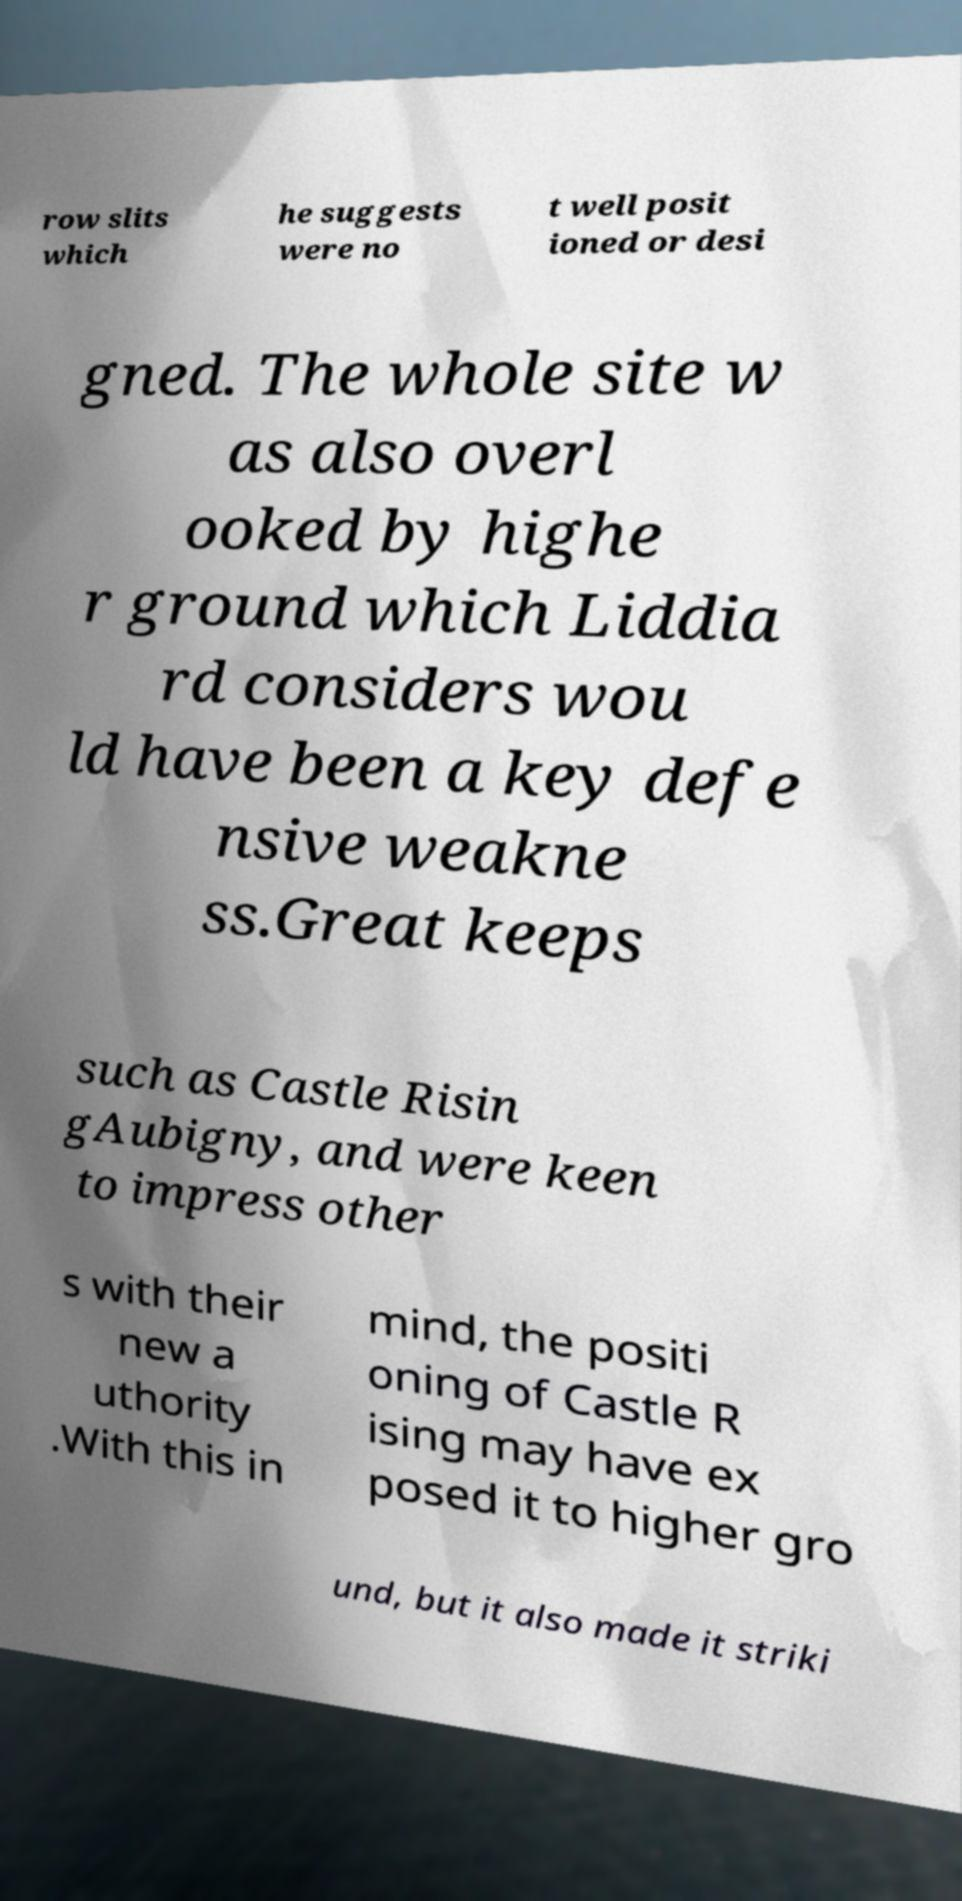Please identify and transcribe the text found in this image. row slits which he suggests were no t well posit ioned or desi gned. The whole site w as also overl ooked by highe r ground which Liddia rd considers wou ld have been a key defe nsive weakne ss.Great keeps such as Castle Risin gAubigny, and were keen to impress other s with their new a uthority .With this in mind, the positi oning of Castle R ising may have ex posed it to higher gro und, but it also made it striki 